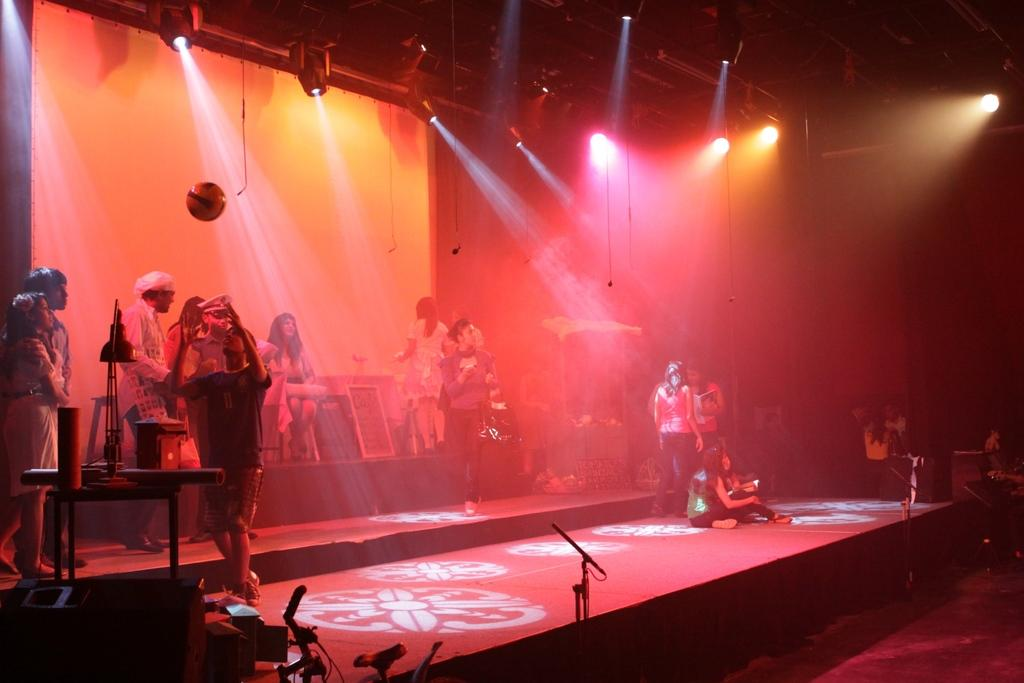What is happening on the stage in the image? There is a group of people on the stage. What can be seen to the left of the stage? There are objects visible to the left of the stage. What can be seen illuminating the stage and the people? There are lights visible in the image. What is written or displayed at the top of the image? There is a banner in the top of the image. How does the sun affect the performance on the stage in the image? The image does not show the sun, so it cannot be determined how it might affect the performance on the stage. 